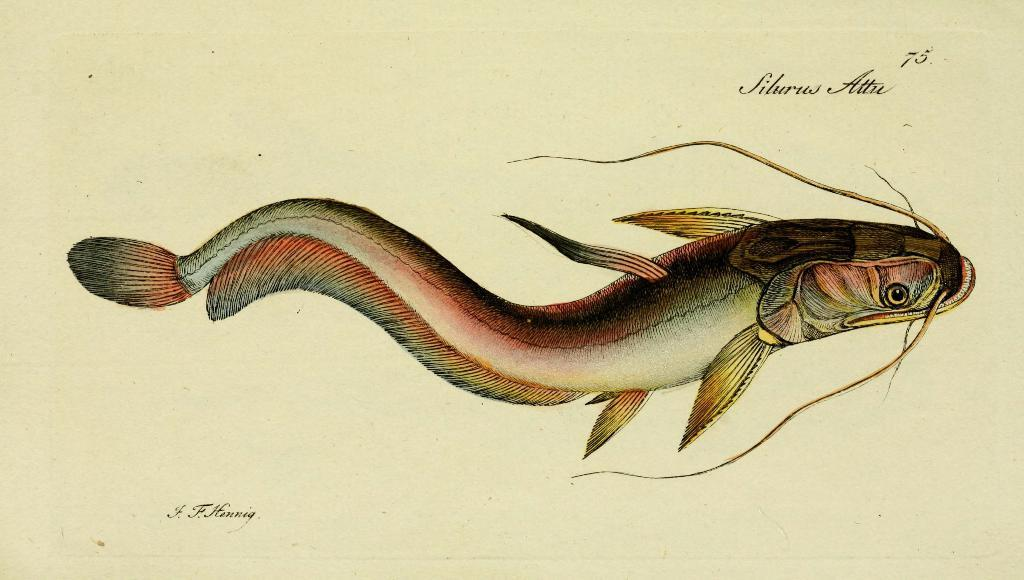What type of animals are depicted in the image? Fish are depicted in the image. What type of battle is taking place between the trucks and the bear in the image? There is no depiction of trucks or a bear in the image; it only features fish. 